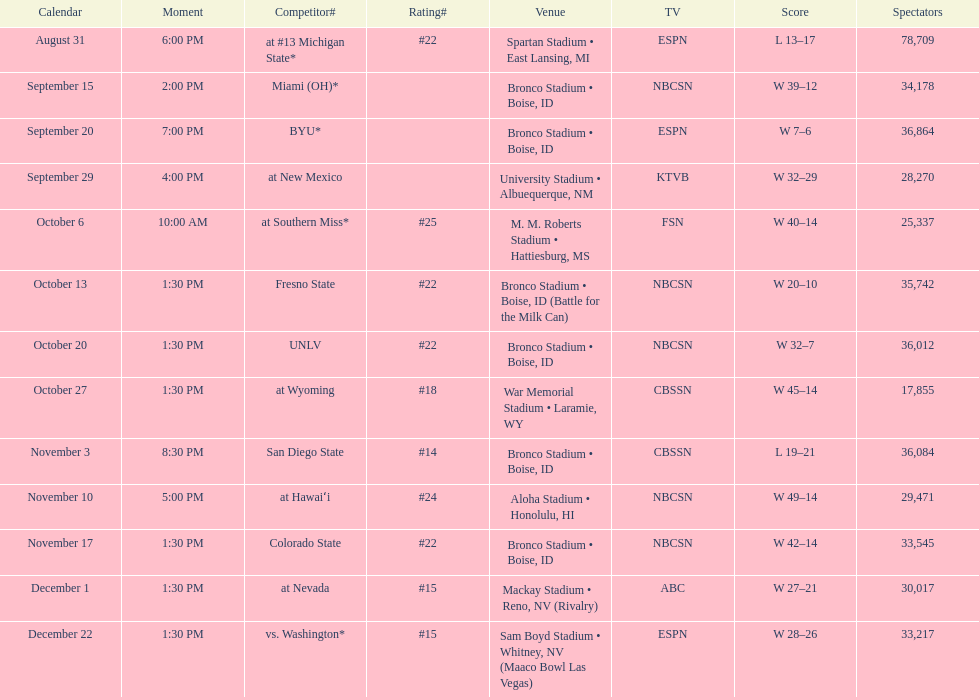What rank was boise state after november 10th? #22. 